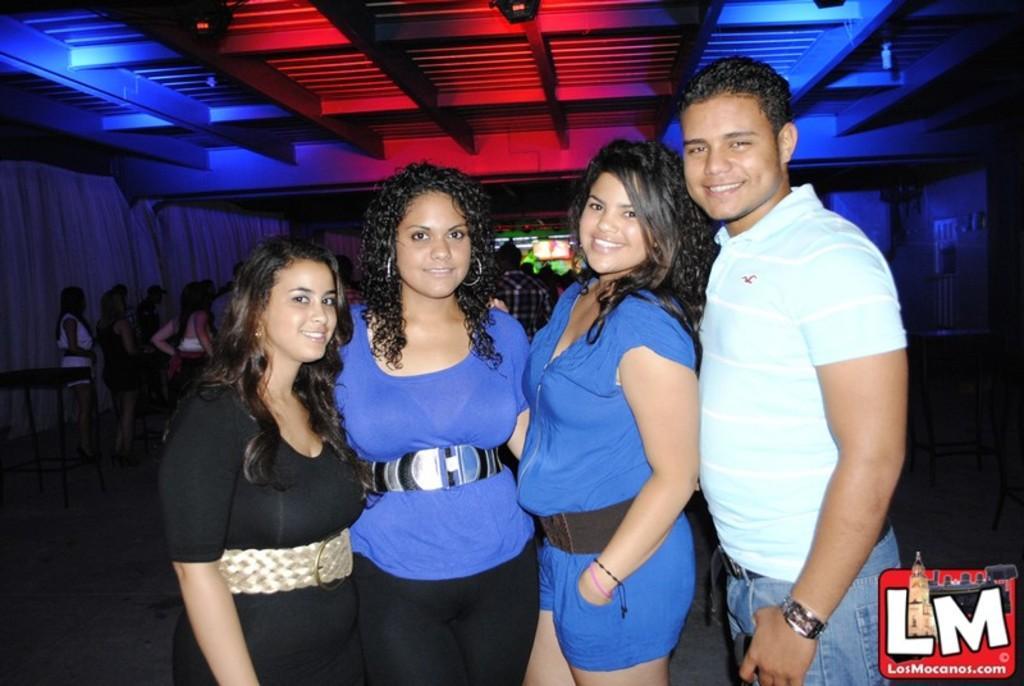Could you give a brief overview of what you see in this image? In this picture we can see four people and they are smiling and in the background we can see few people, table, curtain, wall, roof and few objects, in the bottom right we can see a logo on it. 